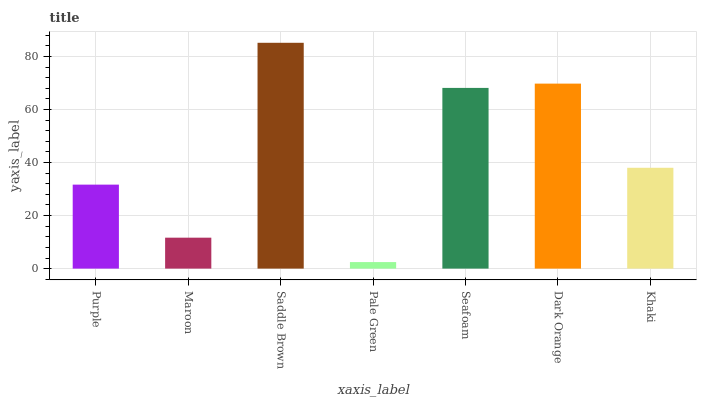Is Pale Green the minimum?
Answer yes or no. Yes. Is Saddle Brown the maximum?
Answer yes or no. Yes. Is Maroon the minimum?
Answer yes or no. No. Is Maroon the maximum?
Answer yes or no. No. Is Purple greater than Maroon?
Answer yes or no. Yes. Is Maroon less than Purple?
Answer yes or no. Yes. Is Maroon greater than Purple?
Answer yes or no. No. Is Purple less than Maroon?
Answer yes or no. No. Is Khaki the high median?
Answer yes or no. Yes. Is Khaki the low median?
Answer yes or no. Yes. Is Dark Orange the high median?
Answer yes or no. No. Is Purple the low median?
Answer yes or no. No. 